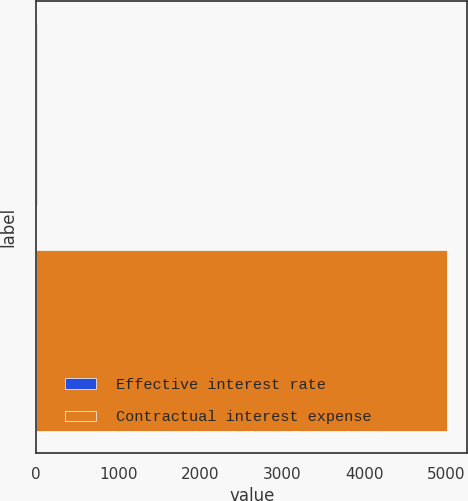<chart> <loc_0><loc_0><loc_500><loc_500><bar_chart><fcel>Effective interest rate<fcel>Contractual interest expense<nl><fcel>8.1<fcel>5005<nl></chart> 